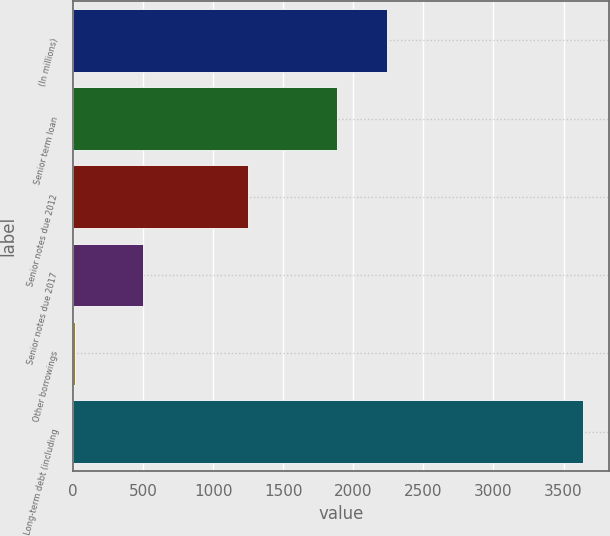Convert chart. <chart><loc_0><loc_0><loc_500><loc_500><bar_chart><fcel>(In millions)<fcel>Senior term loan<fcel>Senior notes due 2012<fcel>Senior notes due 2017<fcel>Other borrowings<fcel>Long-term debt (including<nl><fcel>2242.8<fcel>1880<fcel>1248<fcel>500<fcel>13<fcel>3641<nl></chart> 